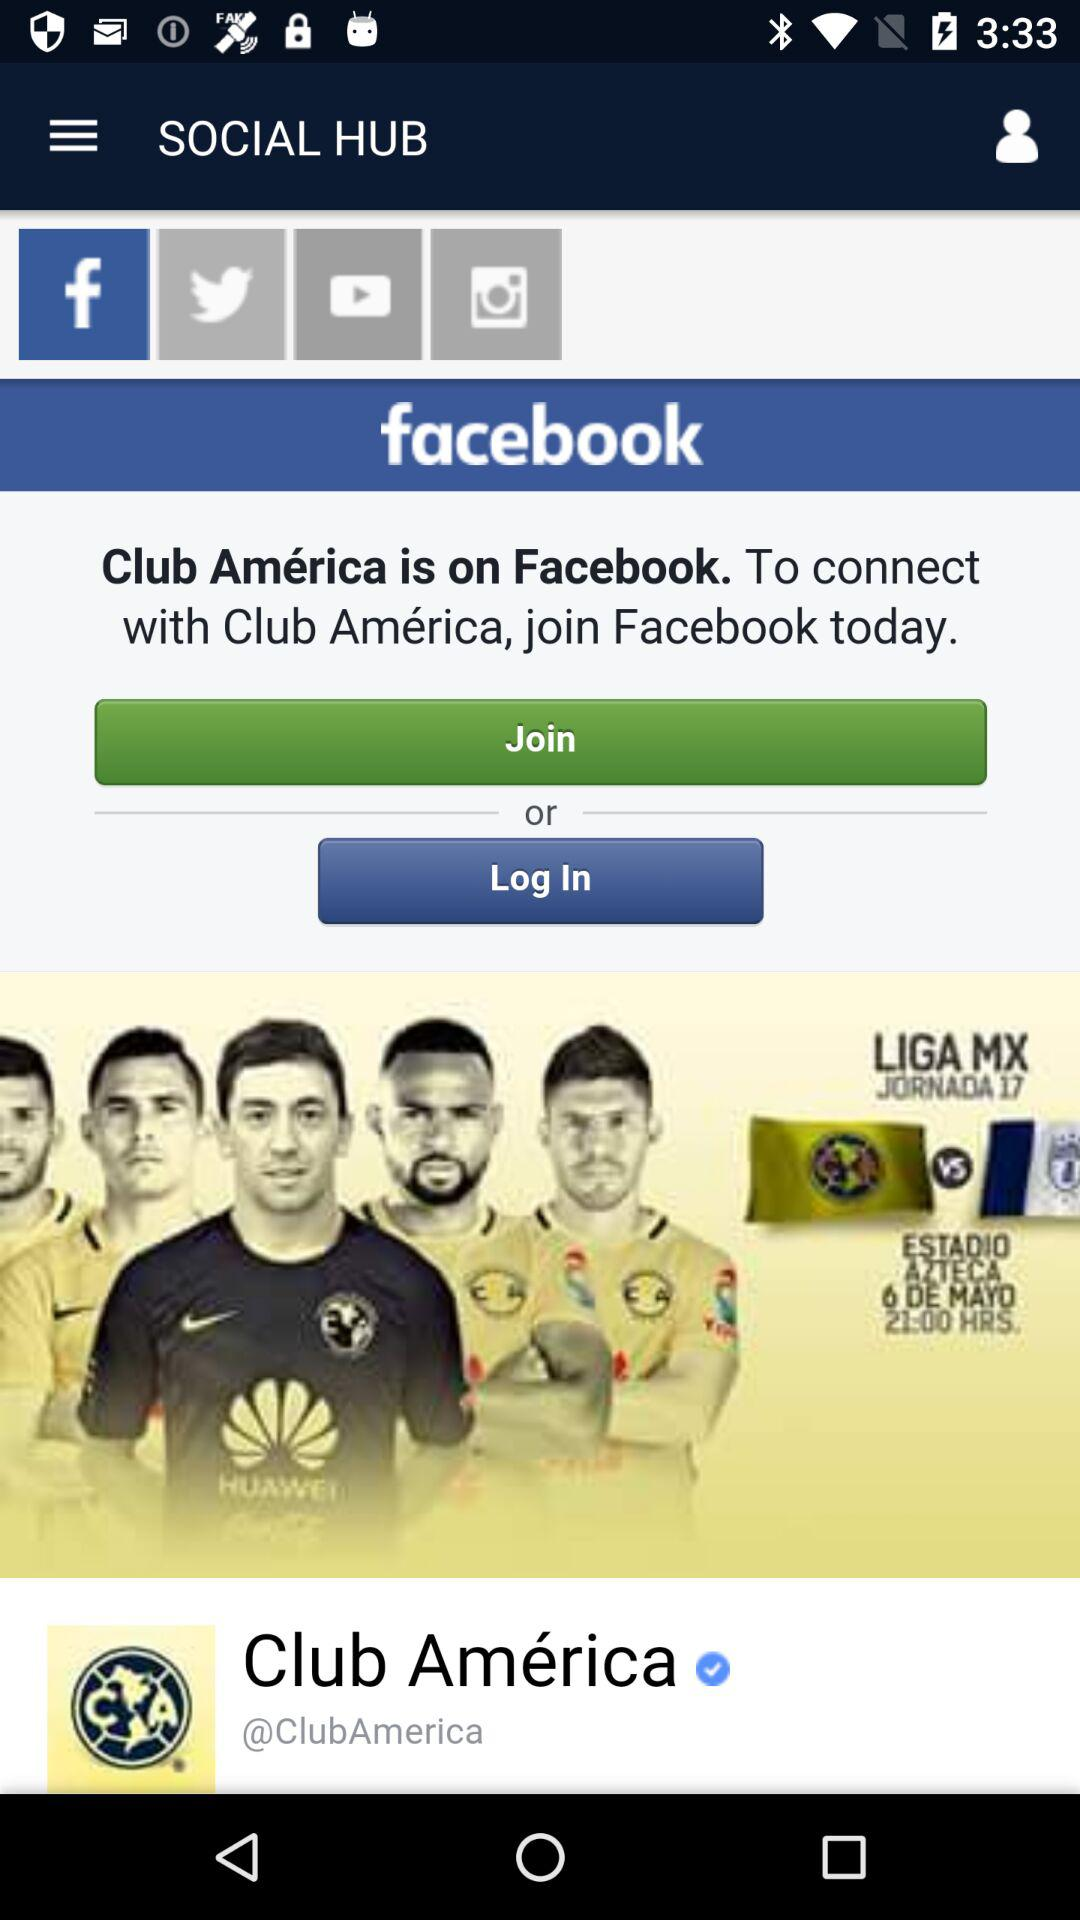What is the name of the football club? The name of the football club is "Club América". 